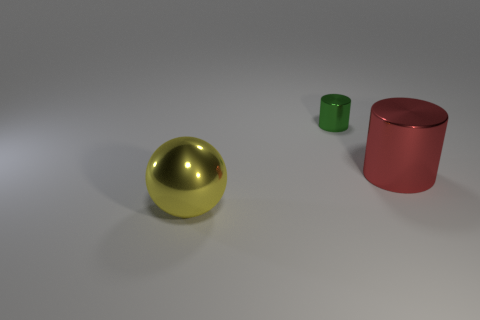Add 2 big yellow metallic spheres. How many objects exist? 5 Subtract all spheres. How many objects are left? 2 Add 3 big yellow balls. How many big yellow balls exist? 4 Subtract 0 brown cylinders. How many objects are left? 3 Subtract all gray rubber objects. Subtract all red metallic things. How many objects are left? 2 Add 1 green objects. How many green objects are left? 2 